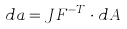<formula> <loc_0><loc_0><loc_500><loc_500>d a = J F ^ { - T } \cdot d A</formula> 